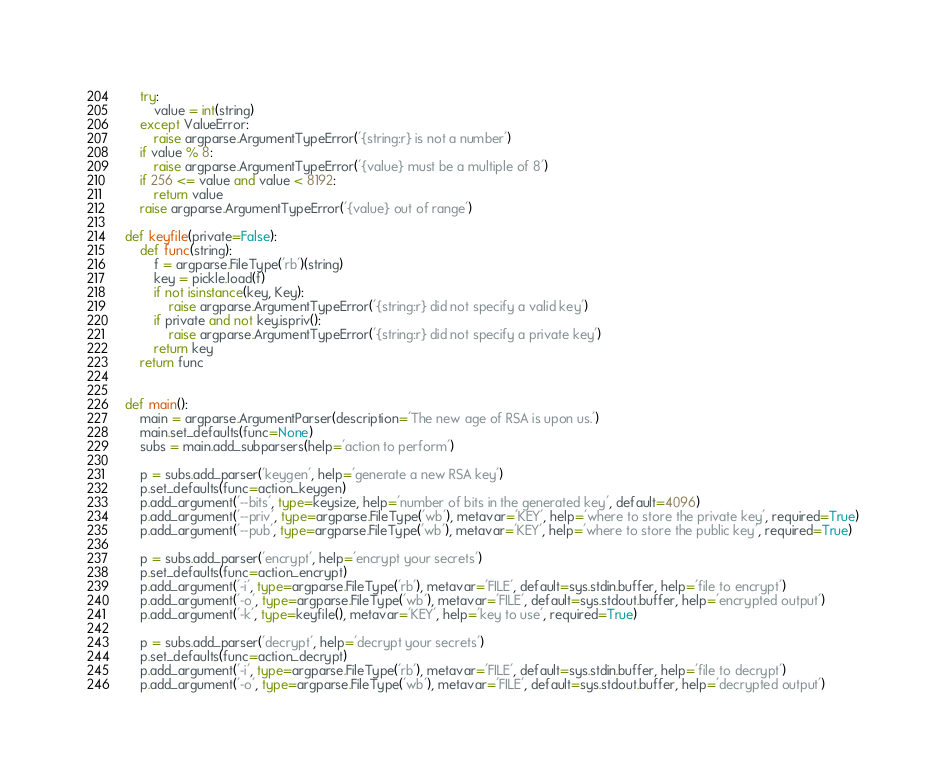<code> <loc_0><loc_0><loc_500><loc_500><_Python_>	try:
		value = int(string)
	except ValueError:
		raise argparse.ArgumentTypeError('{string:r} is not a number')
	if value % 8:
		raise argparse.ArgumentTypeError('{value} must be a multiple of 8')
	if 256 <= value and value < 8192:
		return value
	raise argparse.ArgumentTypeError('{value} out of range')

def keyfile(private=False):
	def func(string):
		f = argparse.FileType('rb')(string)
		key = pickle.load(f)
		if not isinstance(key, Key):
			raise argparse.ArgumentTypeError('{string:r} did not specify a valid key')
		if private and not key.ispriv():
			raise argparse.ArgumentTypeError('{string:r} did not specify a private key')
		return key
	return func


def main():
	main = argparse.ArgumentParser(description='The new age of RSA is upon us.')
	main.set_defaults(func=None)
	subs = main.add_subparsers(help='action to perform')

	p = subs.add_parser('keygen', help='generate a new RSA key')
	p.set_defaults(func=action_keygen)
	p.add_argument('--bits', type=keysize, help='number of bits in the generated key', default=4096)
	p.add_argument('--priv', type=argparse.FileType('wb'), metavar='KEY', help='where to store the private key', required=True)
	p.add_argument('--pub', type=argparse.FileType('wb'), metavar='KEY', help='where to store the public key', required=True)

	p = subs.add_parser('encrypt', help='encrypt your secrets')
	p.set_defaults(func=action_encrypt)
	p.add_argument('-i', type=argparse.FileType('rb'), metavar='FILE', default=sys.stdin.buffer, help='file to encrypt')
	p.add_argument('-o', type=argparse.FileType('wb'), metavar='FILE', default=sys.stdout.buffer, help='encrypted output')
	p.add_argument('-k', type=keyfile(), metavar='KEY', help='key to use', required=True)

	p = subs.add_parser('decrypt', help='decrypt your secrets')
	p.set_defaults(func=action_decrypt)
	p.add_argument('-i', type=argparse.FileType('rb'), metavar='FILE', default=sys.stdin.buffer, help='file to decrypt')
	p.add_argument('-o', type=argparse.FileType('wb'), metavar='FILE', default=sys.stdout.buffer, help='decrypted output')</code> 